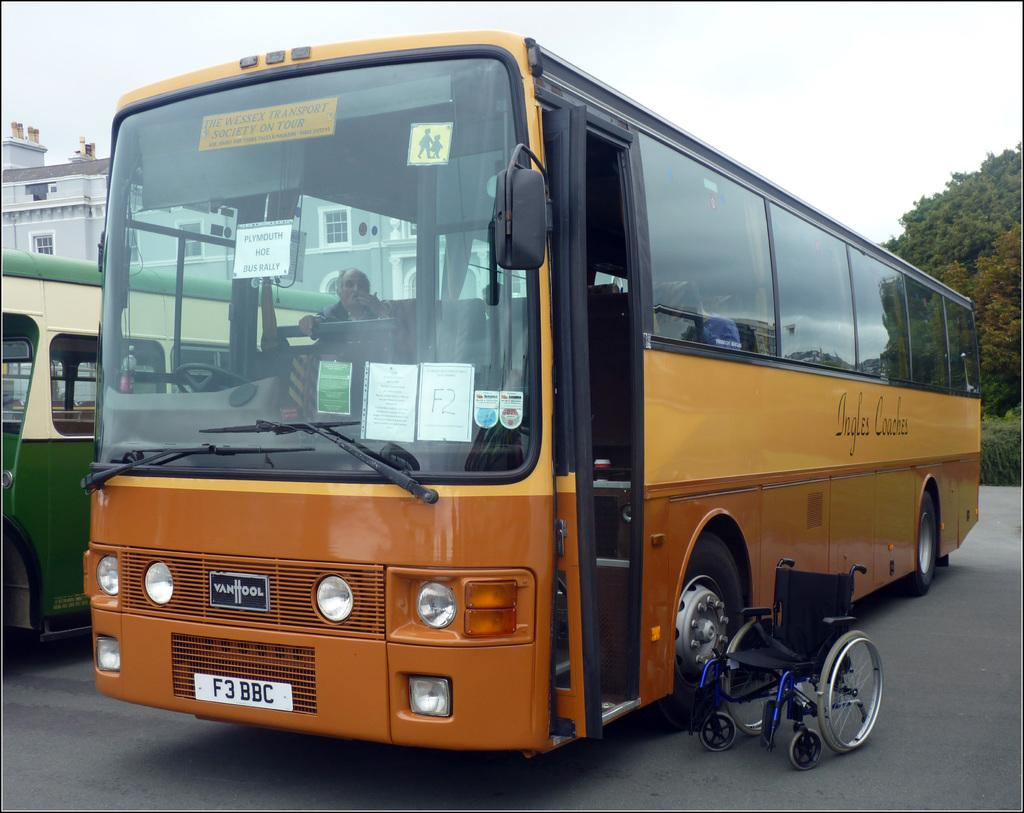<image>
Create a compact narrative representing the image presented. An Orange-Yellow VanHool bus is near a Green-Beige bus. 